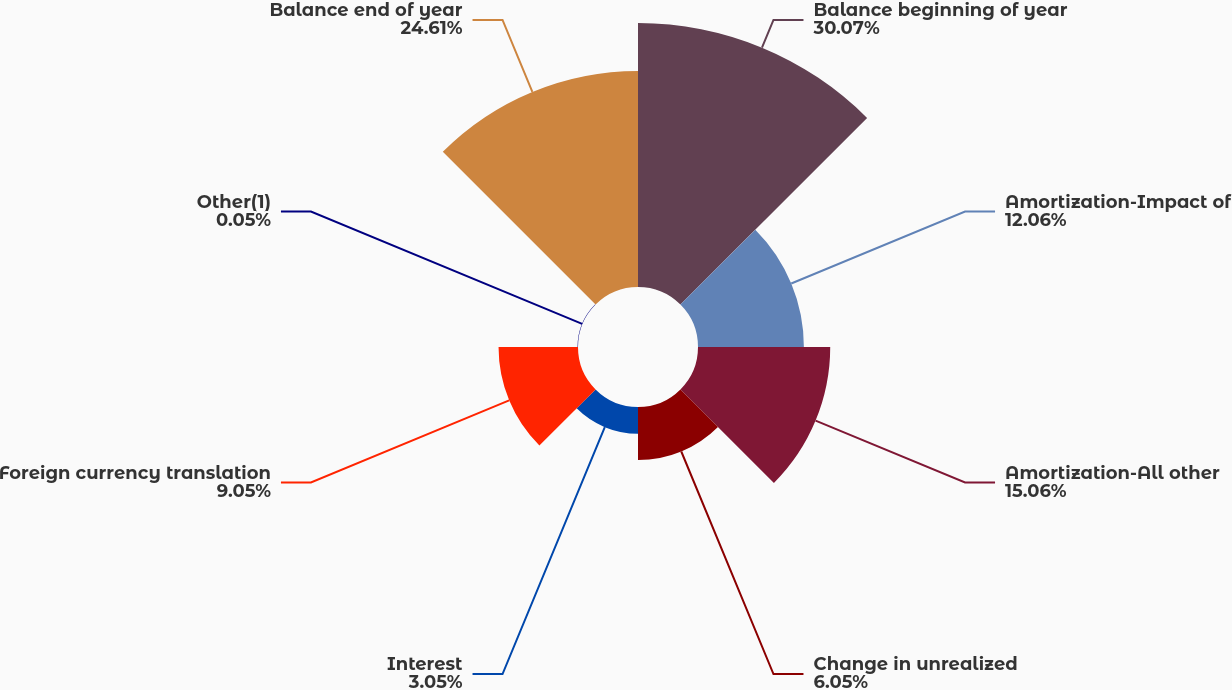<chart> <loc_0><loc_0><loc_500><loc_500><pie_chart><fcel>Balance beginning of year<fcel>Amortization-Impact of<fcel>Amortization-All other<fcel>Change in unrealized<fcel>Interest<fcel>Foreign currency translation<fcel>Other(1)<fcel>Balance end of year<nl><fcel>30.07%<fcel>12.06%<fcel>15.06%<fcel>6.05%<fcel>3.05%<fcel>9.05%<fcel>0.05%<fcel>24.61%<nl></chart> 